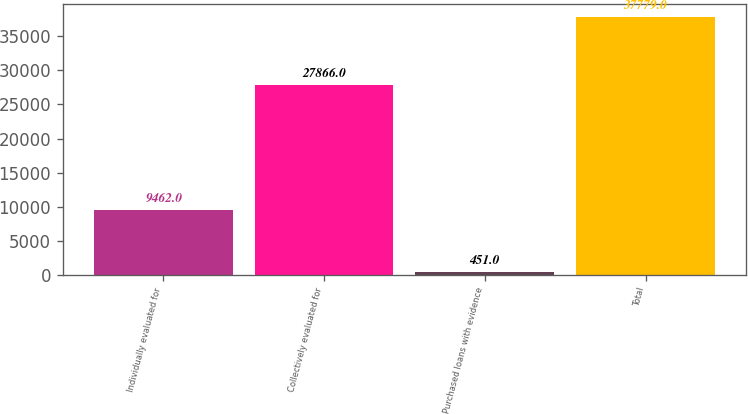<chart> <loc_0><loc_0><loc_500><loc_500><bar_chart><fcel>Individually evaluated for<fcel>Collectively evaluated for<fcel>Purchased loans with evidence<fcel>Total<nl><fcel>9462<fcel>27866<fcel>451<fcel>37779<nl></chart> 